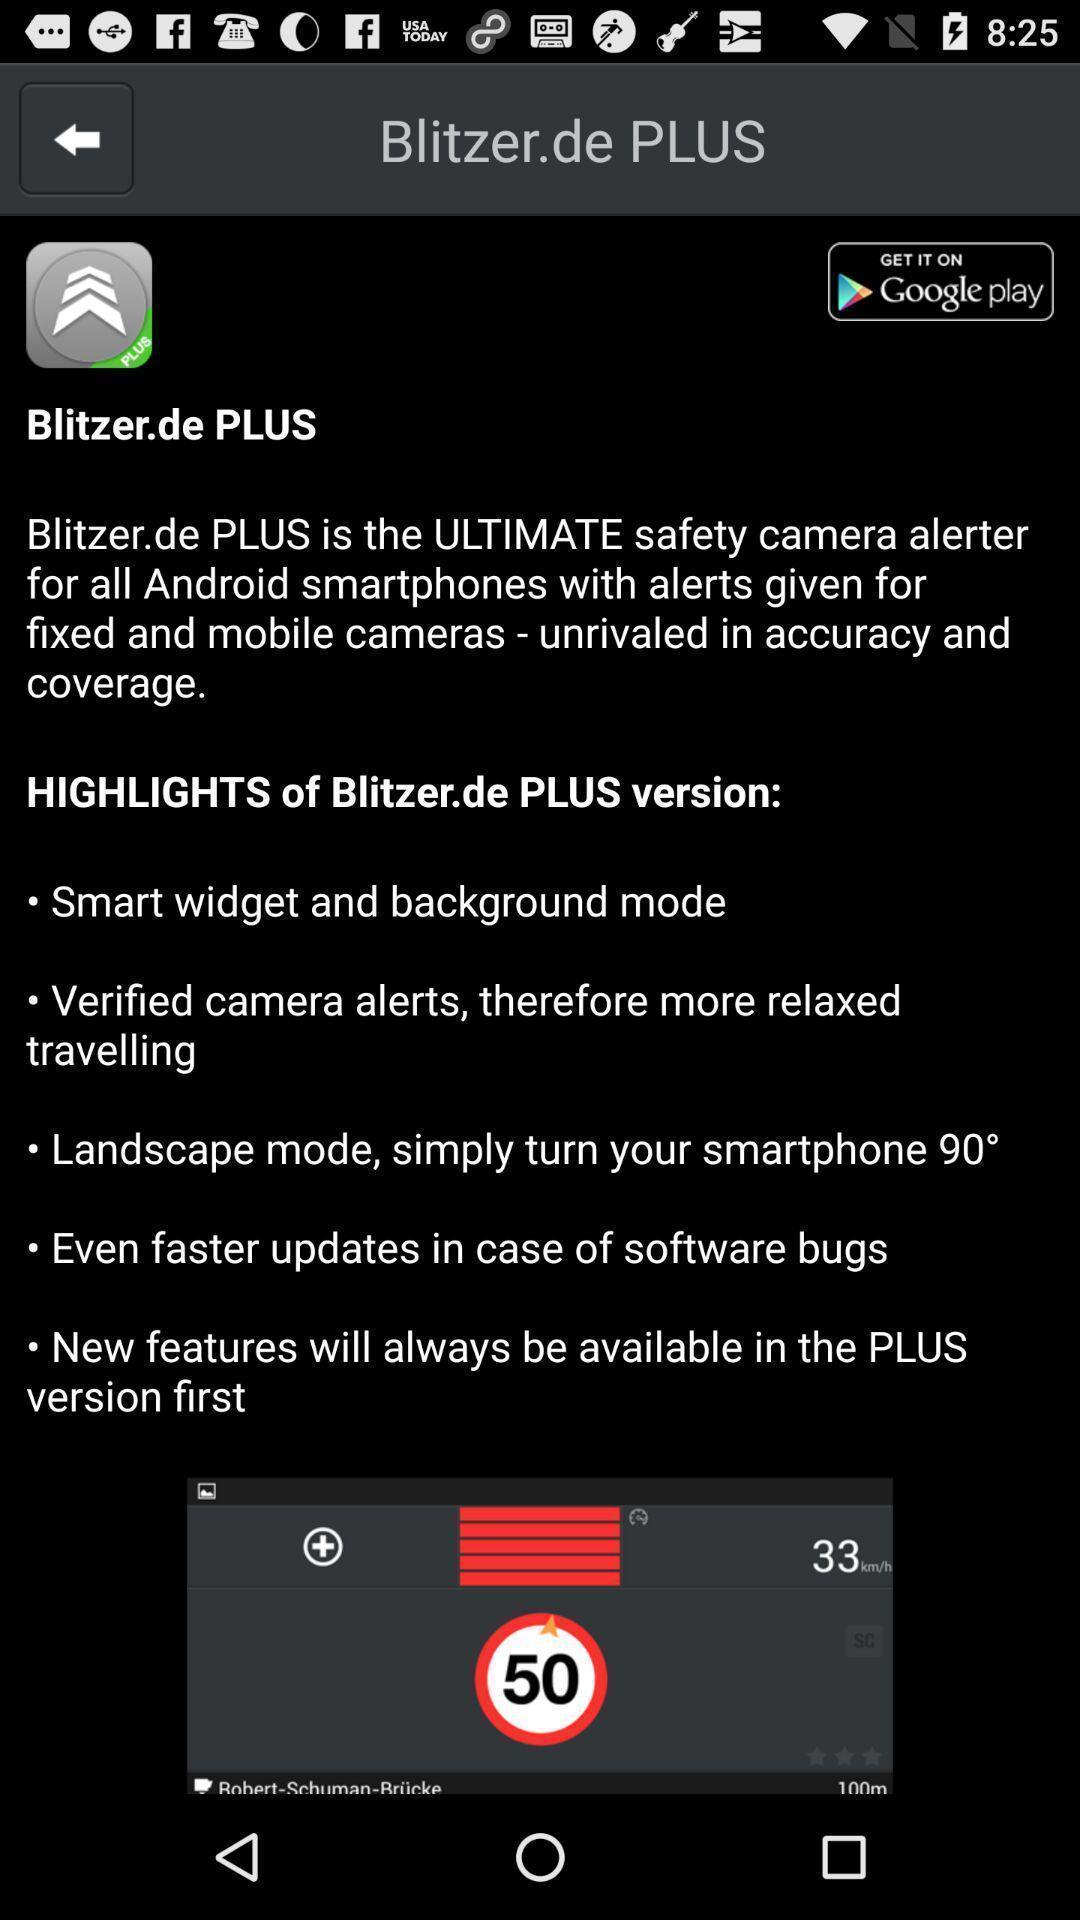Explain the elements present in this screenshot. Screen shows version details. 